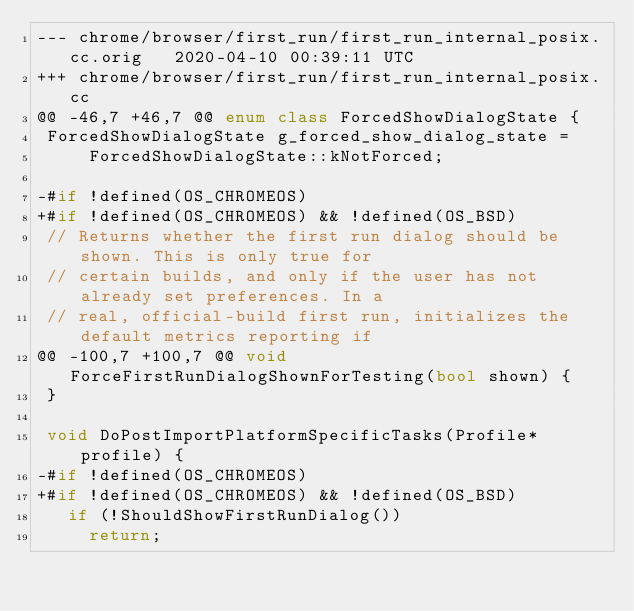Convert code to text. <code><loc_0><loc_0><loc_500><loc_500><_C++_>--- chrome/browser/first_run/first_run_internal_posix.cc.orig	2020-04-10 00:39:11 UTC
+++ chrome/browser/first_run/first_run_internal_posix.cc
@@ -46,7 +46,7 @@ enum class ForcedShowDialogState {
 ForcedShowDialogState g_forced_show_dialog_state =
     ForcedShowDialogState::kNotForced;
 
-#if !defined(OS_CHROMEOS)
+#if !defined(OS_CHROMEOS) && !defined(OS_BSD)
 // Returns whether the first run dialog should be shown. This is only true for
 // certain builds, and only if the user has not already set preferences. In a
 // real, official-build first run, initializes the default metrics reporting if
@@ -100,7 +100,7 @@ void ForceFirstRunDialogShownForTesting(bool shown) {
 }
 
 void DoPostImportPlatformSpecificTasks(Profile* profile) {
-#if !defined(OS_CHROMEOS)
+#if !defined(OS_CHROMEOS) && !defined(OS_BSD)
   if (!ShouldShowFirstRunDialog())
     return;
 
</code> 